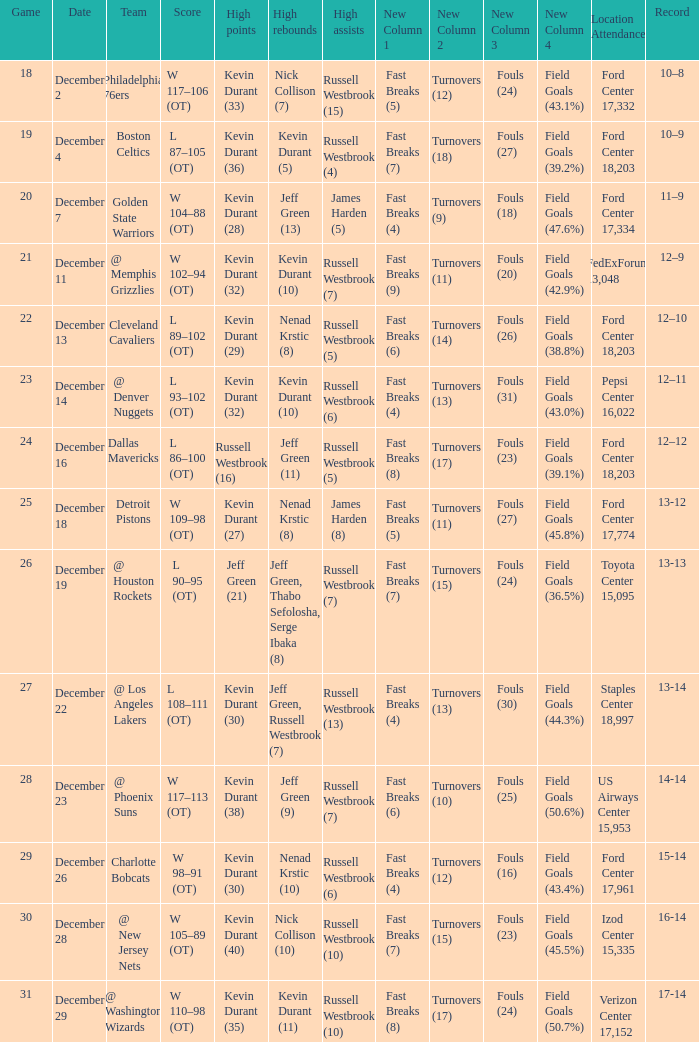Who has high points when verizon center 17,152 is location attendance? Kevin Durant (35). 